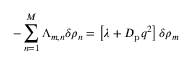Convert formula to latex. <formula><loc_0><loc_0><loc_500><loc_500>- \sum _ { n = 1 } ^ { M } \Lambda _ { m , n } \delta \rho _ { n } = \left [ \lambda + D _ { p } q ^ { 2 } \right ] \delta \rho _ { m }</formula> 